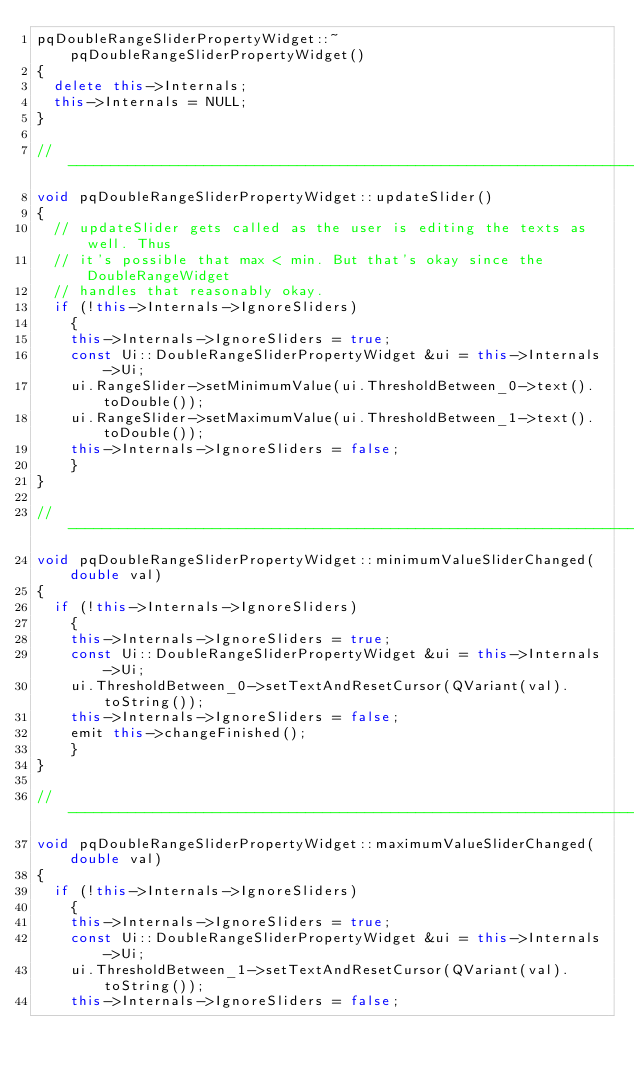Convert code to text. <code><loc_0><loc_0><loc_500><loc_500><_C++_>pqDoubleRangeSliderPropertyWidget::~pqDoubleRangeSliderPropertyWidget()
{
  delete this->Internals;
  this->Internals = NULL;
}

//-----------------------------------------------------------------------------
void pqDoubleRangeSliderPropertyWidget::updateSlider()
{
  // updateSlider gets called as the user is editing the texts as well. Thus
  // it's possible that max < min. But that's okay since the DoubleRangeWidget
  // handles that reasonably okay.
  if (!this->Internals->IgnoreSliders)
    {
    this->Internals->IgnoreSliders = true;
    const Ui::DoubleRangeSliderPropertyWidget &ui = this->Internals->Ui;
    ui.RangeSlider->setMinimumValue(ui.ThresholdBetween_0->text().toDouble());
    ui.RangeSlider->setMaximumValue(ui.ThresholdBetween_1->text().toDouble());
    this->Internals->IgnoreSliders = false;
    }
}

//-----------------------------------------------------------------------------
void pqDoubleRangeSliderPropertyWidget::minimumValueSliderChanged(double val)
{
  if (!this->Internals->IgnoreSliders)
    {
    this->Internals->IgnoreSliders = true;
    const Ui::DoubleRangeSliderPropertyWidget &ui = this->Internals->Ui;
    ui.ThresholdBetween_0->setTextAndResetCursor(QVariant(val).toString());
    this->Internals->IgnoreSliders = false;
    emit this->changeFinished();
    }
}

//-----------------------------------------------------------------------------
void pqDoubleRangeSliderPropertyWidget::maximumValueSliderChanged(double val)
{
  if (!this->Internals->IgnoreSliders)
    {
    this->Internals->IgnoreSliders = true;
    const Ui::DoubleRangeSliderPropertyWidget &ui = this->Internals->Ui;
    ui.ThresholdBetween_1->setTextAndResetCursor(QVariant(val).toString());
    this->Internals->IgnoreSliders = false;</code> 